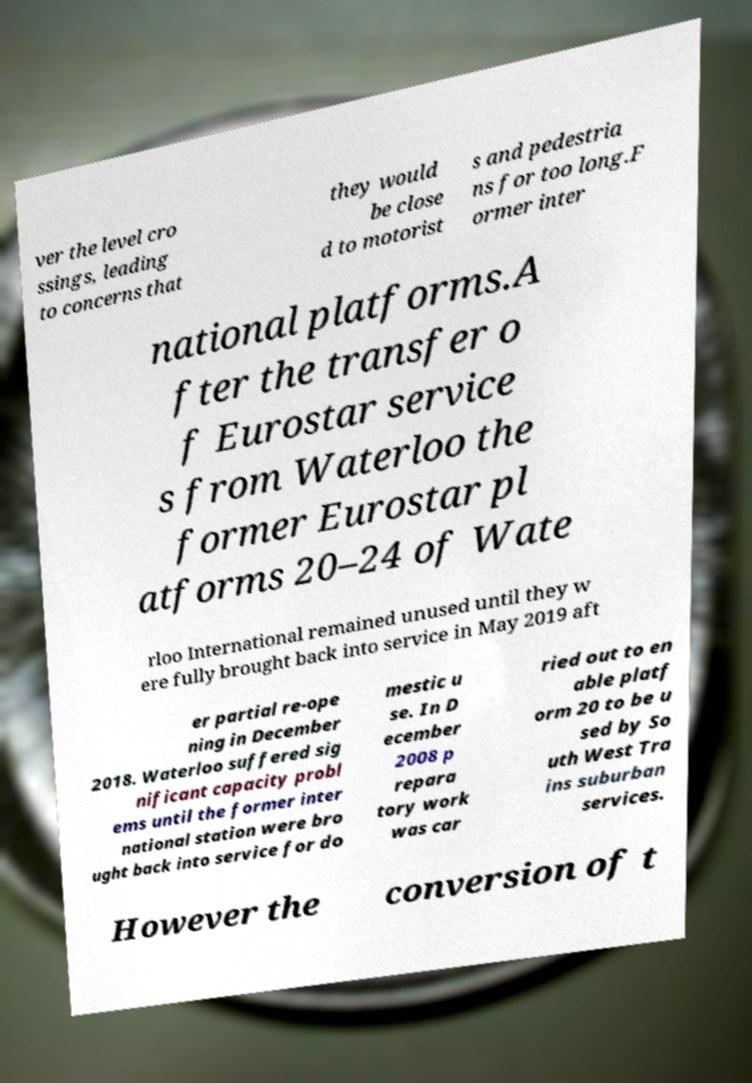Could you extract and type out the text from this image? ver the level cro ssings, leading to concerns that they would be close d to motorist s and pedestria ns for too long.F ormer inter national platforms.A fter the transfer o f Eurostar service s from Waterloo the former Eurostar pl atforms 20–24 of Wate rloo International remained unused until they w ere fully brought back into service in May 2019 aft er partial re-ope ning in December 2018. Waterloo suffered sig nificant capacity probl ems until the former inter national station were bro ught back into service for do mestic u se. In D ecember 2008 p repara tory work was car ried out to en able platf orm 20 to be u sed by So uth West Tra ins suburban services. However the conversion of t 